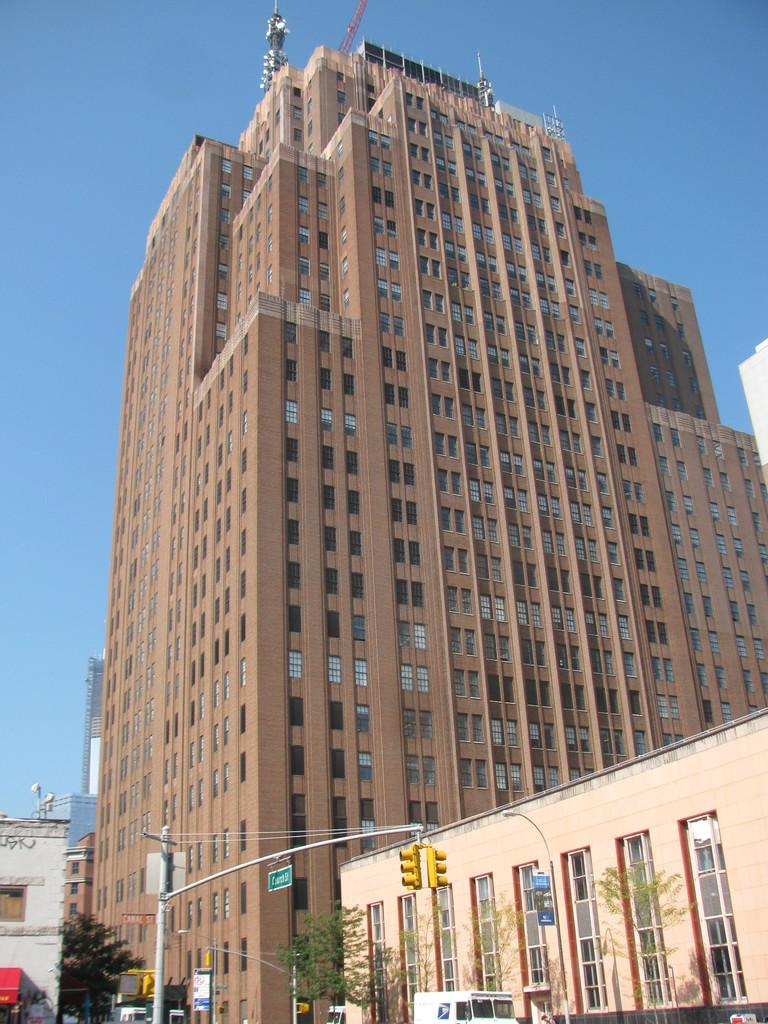What type of structures can be seen in the image? There are buildings in the image. What is happening on the road at the bottom of the image? There are vehicles moving on the road at the bottom of the image. What type of vegetation is present in the image? There are trees in the image. What is the tall, thin object in the image? There is a signal pole in the image. What can be seen in the background of the image? The sky is visible in the background of the image. Can you tell me how many units of cake are being sold at the signal pole in the image? There is no cake or sale of any kind present at the signal pole in the image. How does the runway look like in the image? There is no runway present in the image; it features buildings, vehicles, trees, a signal pole, and the sky. 